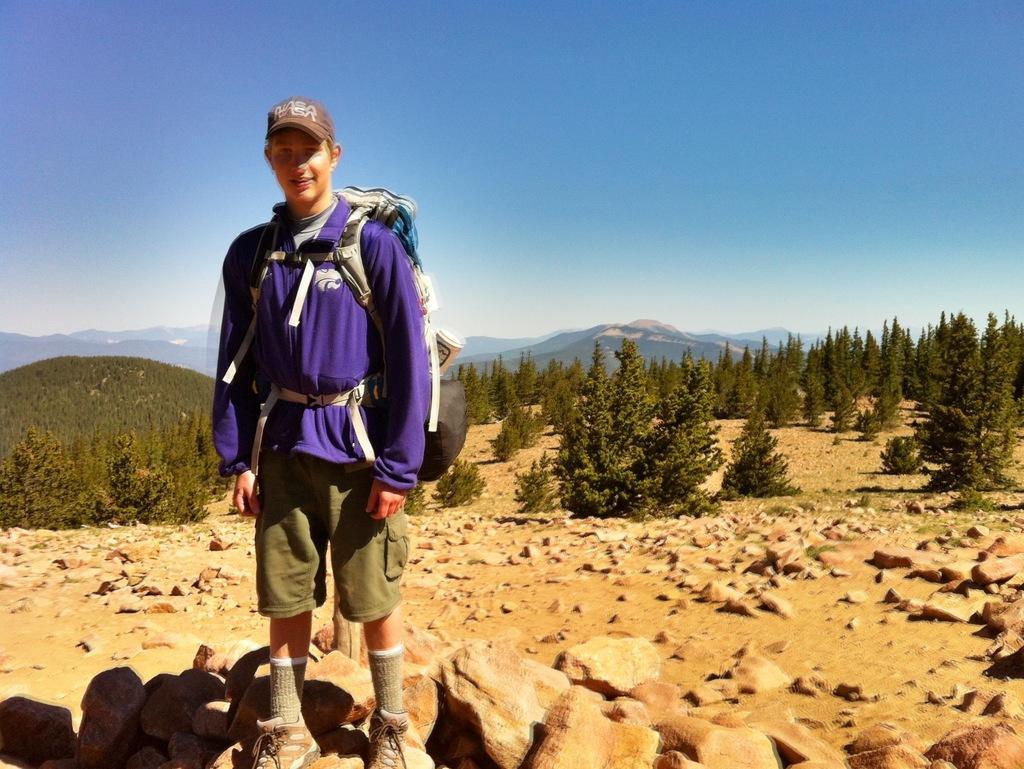In one or two sentences, can you explain what this image depicts? In this picture we can see a man. He is in blue color jacket. He wear a cap and these are the stones. On the background we can see some trees. 